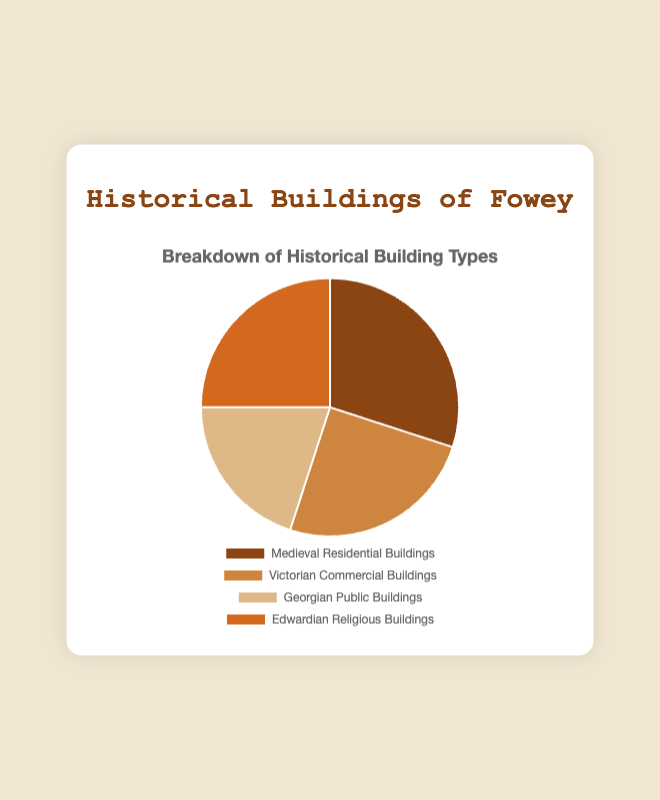What's the most common type of historical building in Fowey? The pie chart shows that the largest percentage of buildings belongs to Medieval Residential Buildings at 30%.
Answer: Medieval Residential Buildings Which two types of buildings are equally represented in Fowey? According to the pie chart, Victorian Commercial Buildings and Edwardian Religious Buildings each make up 25%.
Answer: Victorian Commercial Buildings and Edwardian Religious Buildings What is the combined percentage of Victorian Commercial and Edwardian Religious Buildings? Both types each constitute 25% of the pie chart. Therefore, their combined percentage is 25% + 25%.
Answer: 50% What's the least common type of historical building? The pie chart shows that Georgian Public Buildings have the smallest segment at 20%.
Answer: Georgian Public Buildings How much more common are Medieval Residential Buildings compared to Georgian Public Buildings? Medieval Residential Buildings account for 30% while Georgian Public Buildings account for 20%. The difference is 30% - 20%.
Answer: 10% Which type of building has a brownish color while being the least common? The pie chart associates 20% (the least common percentage) with Georgian Public Buildings, and it has a brownish color.
Answer: Georgian Public Buildings If you were to visit two random historical buildings in Fowey, what is the probability that both would be either Victorian Commercial or Edwardian Religious buildings? Both Victorian Commercial and Edwardian Religious Buildings represent 25% each. The probability of selecting either type in two random picks is 0.25 * 0.25 = 0.0625 or 6.25%.
Answer: 6.25% What's the average percentage of all the building types depicted? Adding the percentages: 30% + 25% + 20% + 25% gives 100%. Dividing by the four categories: 100% / 4.
Answer: 25% What proportion of the buildings depicted belongs to either Medieval or Edwardian styles? The pie chart shows Medieval Residential at 30% and Edwardian Religious at 25%. Sum: 30% + 25%.
Answer: 55% 